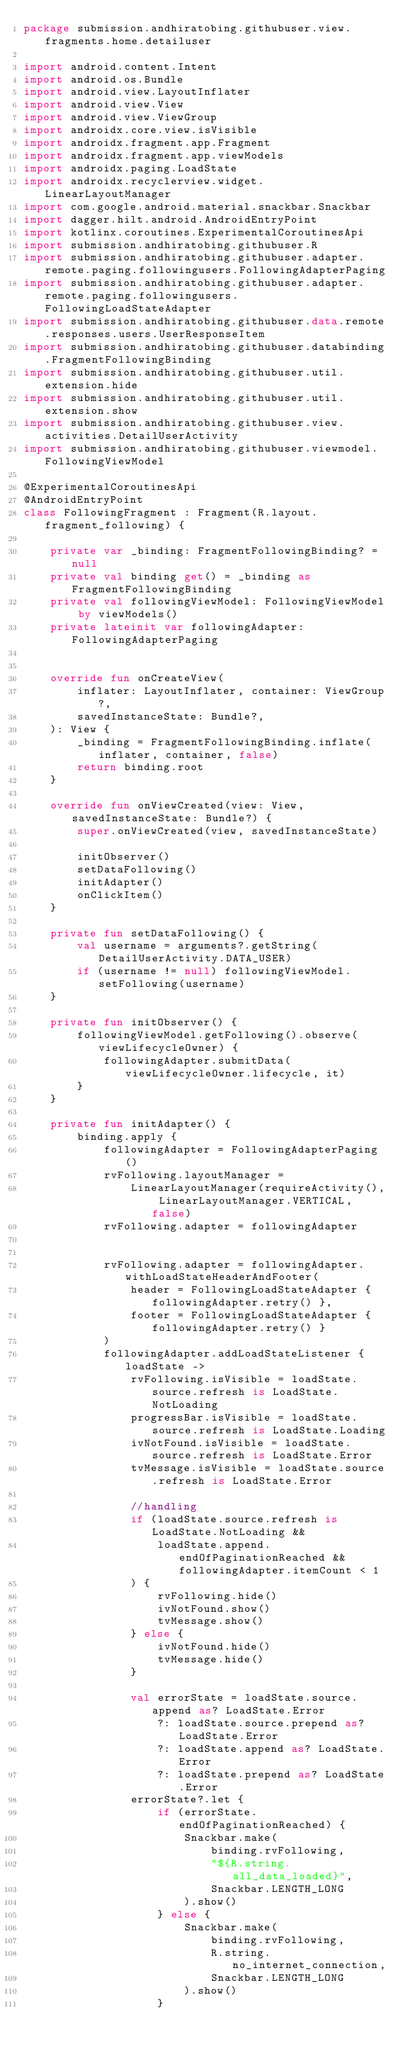<code> <loc_0><loc_0><loc_500><loc_500><_Kotlin_>package submission.andhiratobing.githubuser.view.fragments.home.detailuser

import android.content.Intent
import android.os.Bundle
import android.view.LayoutInflater
import android.view.View
import android.view.ViewGroup
import androidx.core.view.isVisible
import androidx.fragment.app.Fragment
import androidx.fragment.app.viewModels
import androidx.paging.LoadState
import androidx.recyclerview.widget.LinearLayoutManager
import com.google.android.material.snackbar.Snackbar
import dagger.hilt.android.AndroidEntryPoint
import kotlinx.coroutines.ExperimentalCoroutinesApi
import submission.andhiratobing.githubuser.R
import submission.andhiratobing.githubuser.adapter.remote.paging.followingusers.FollowingAdapterPaging
import submission.andhiratobing.githubuser.adapter.remote.paging.followingusers.FollowingLoadStateAdapter
import submission.andhiratobing.githubuser.data.remote.responses.users.UserResponseItem
import submission.andhiratobing.githubuser.databinding.FragmentFollowingBinding
import submission.andhiratobing.githubuser.util.extension.hide
import submission.andhiratobing.githubuser.util.extension.show
import submission.andhiratobing.githubuser.view.activities.DetailUserActivity
import submission.andhiratobing.githubuser.viewmodel.FollowingViewModel

@ExperimentalCoroutinesApi
@AndroidEntryPoint
class FollowingFragment : Fragment(R.layout.fragment_following) {

    private var _binding: FragmentFollowingBinding? = null
    private val binding get() = _binding as FragmentFollowingBinding
    private val followingViewModel: FollowingViewModel by viewModels()
    private lateinit var followingAdapter: FollowingAdapterPaging


    override fun onCreateView(
        inflater: LayoutInflater, container: ViewGroup?,
        savedInstanceState: Bundle?,
    ): View {
        _binding = FragmentFollowingBinding.inflate(inflater, container, false)
        return binding.root
    }

    override fun onViewCreated(view: View, savedInstanceState: Bundle?) {
        super.onViewCreated(view, savedInstanceState)

        initObserver()
        setDataFollowing()
        initAdapter()
        onClickItem()
    }

    private fun setDataFollowing() {
        val username = arguments?.getString(DetailUserActivity.DATA_USER)
        if (username != null) followingViewModel.setFollowing(username)
    }

    private fun initObserver() {
        followingViewModel.getFollowing().observe(viewLifecycleOwner) {
            followingAdapter.submitData(viewLifecycleOwner.lifecycle, it)
        }
    }

    private fun initAdapter() {
        binding.apply {
            followingAdapter = FollowingAdapterPaging()
            rvFollowing.layoutManager =
                LinearLayoutManager(requireActivity(), LinearLayoutManager.VERTICAL, false)
            rvFollowing.adapter = followingAdapter


            rvFollowing.adapter = followingAdapter.withLoadStateHeaderAndFooter(
                header = FollowingLoadStateAdapter { followingAdapter.retry() },
                footer = FollowingLoadStateAdapter { followingAdapter.retry() }
            )
            followingAdapter.addLoadStateListener { loadState ->
                rvFollowing.isVisible = loadState.source.refresh is LoadState.NotLoading
                progressBar.isVisible = loadState.source.refresh is LoadState.Loading
                ivNotFound.isVisible = loadState.source.refresh is LoadState.Error
                tvMessage.isVisible = loadState.source.refresh is LoadState.Error

                //handling
                if (loadState.source.refresh is LoadState.NotLoading &&
                    loadState.append.endOfPaginationReached && followingAdapter.itemCount < 1
                ) {
                    rvFollowing.hide()
                    ivNotFound.show()
                    tvMessage.show()
                } else {
                    ivNotFound.hide()
                    tvMessage.hide()
                }

                val errorState = loadState.source.append as? LoadState.Error
                    ?: loadState.source.prepend as? LoadState.Error
                    ?: loadState.append as? LoadState.Error
                    ?: loadState.prepend as? LoadState.Error
                errorState?.let {
                    if (errorState.endOfPaginationReached) {
                        Snackbar.make(
                            binding.rvFollowing,
                            "${R.string.all_data_loaded}",
                            Snackbar.LENGTH_LONG
                        ).show()
                    } else {
                        Snackbar.make(
                            binding.rvFollowing,
                            R.string.no_internet_connection,
                            Snackbar.LENGTH_LONG
                        ).show()
                    }</code> 